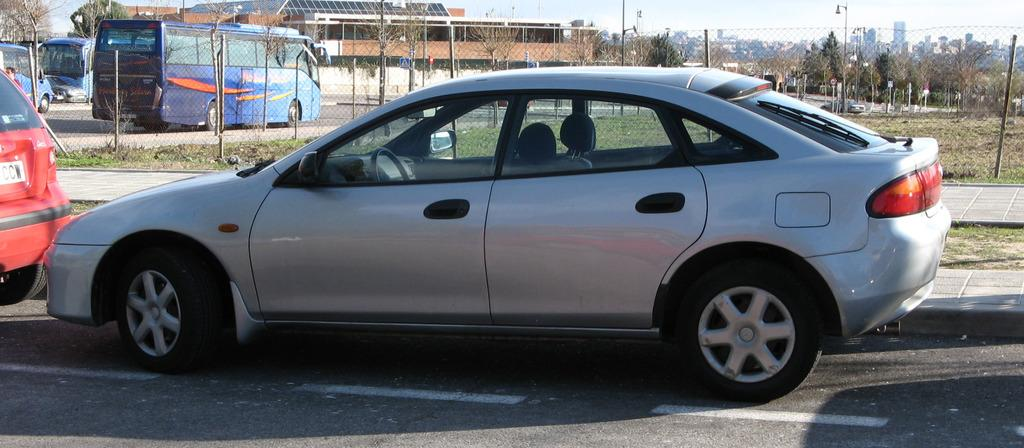What can be seen on the road in the image? There are vehicles on the road in the image. What is visible in the background of the image? In the background of the image, there are poles, buildings, boards, fences, and towers. What is visible at the top of the image? The sky is visible at the top of the image. Can you see a match being lit in the image? There is no match present in the image. What part of the human body is visible in the image? There are no human body parts visible in the image. 